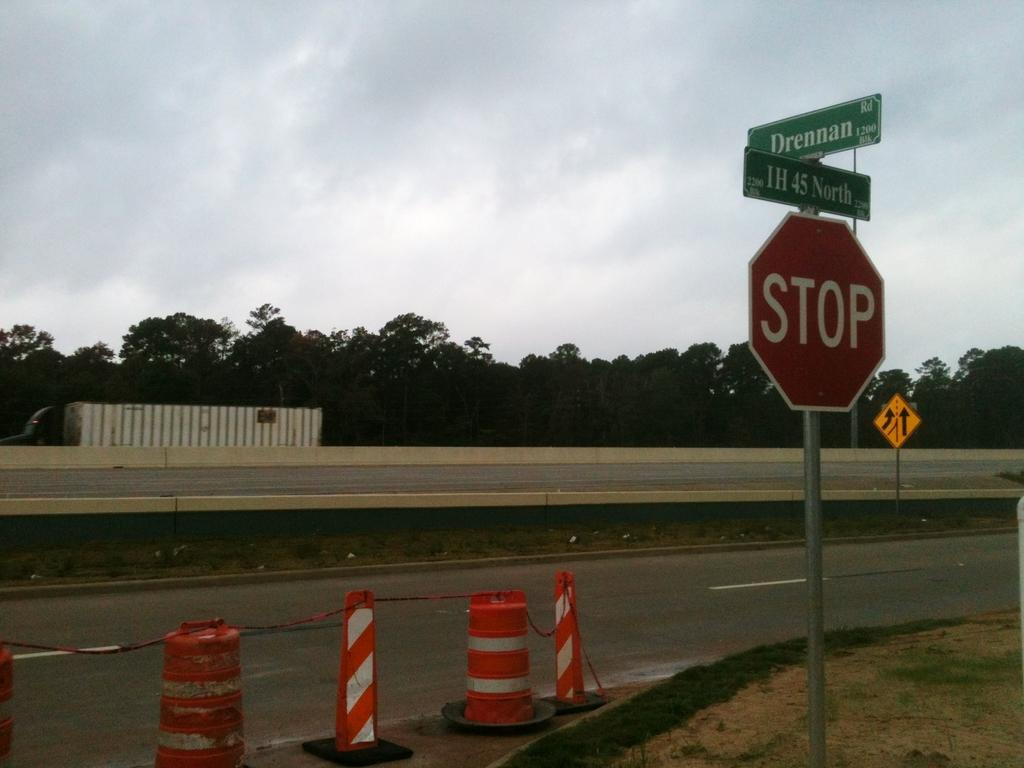<image>
Summarize the visual content of the image. A row of street cones blocking off a road are by a sign that says Stop. 